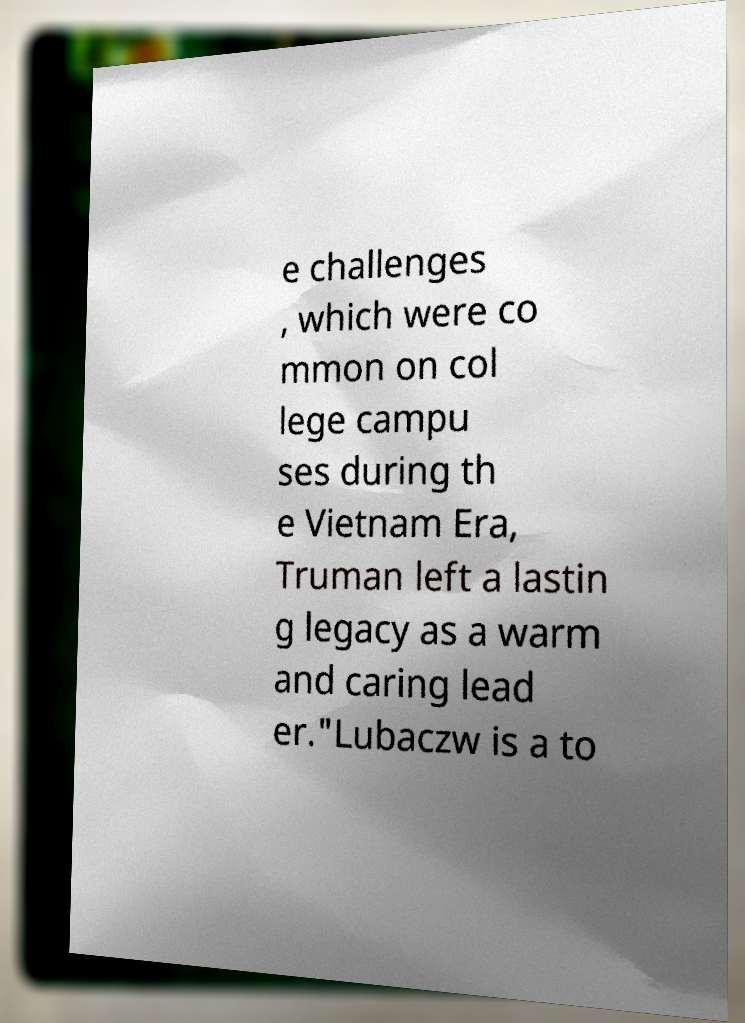Could you assist in decoding the text presented in this image and type it out clearly? e challenges , which were co mmon on col lege campu ses during th e Vietnam Era, Truman left a lastin g legacy as a warm and caring lead er."Lubaczw is a to 